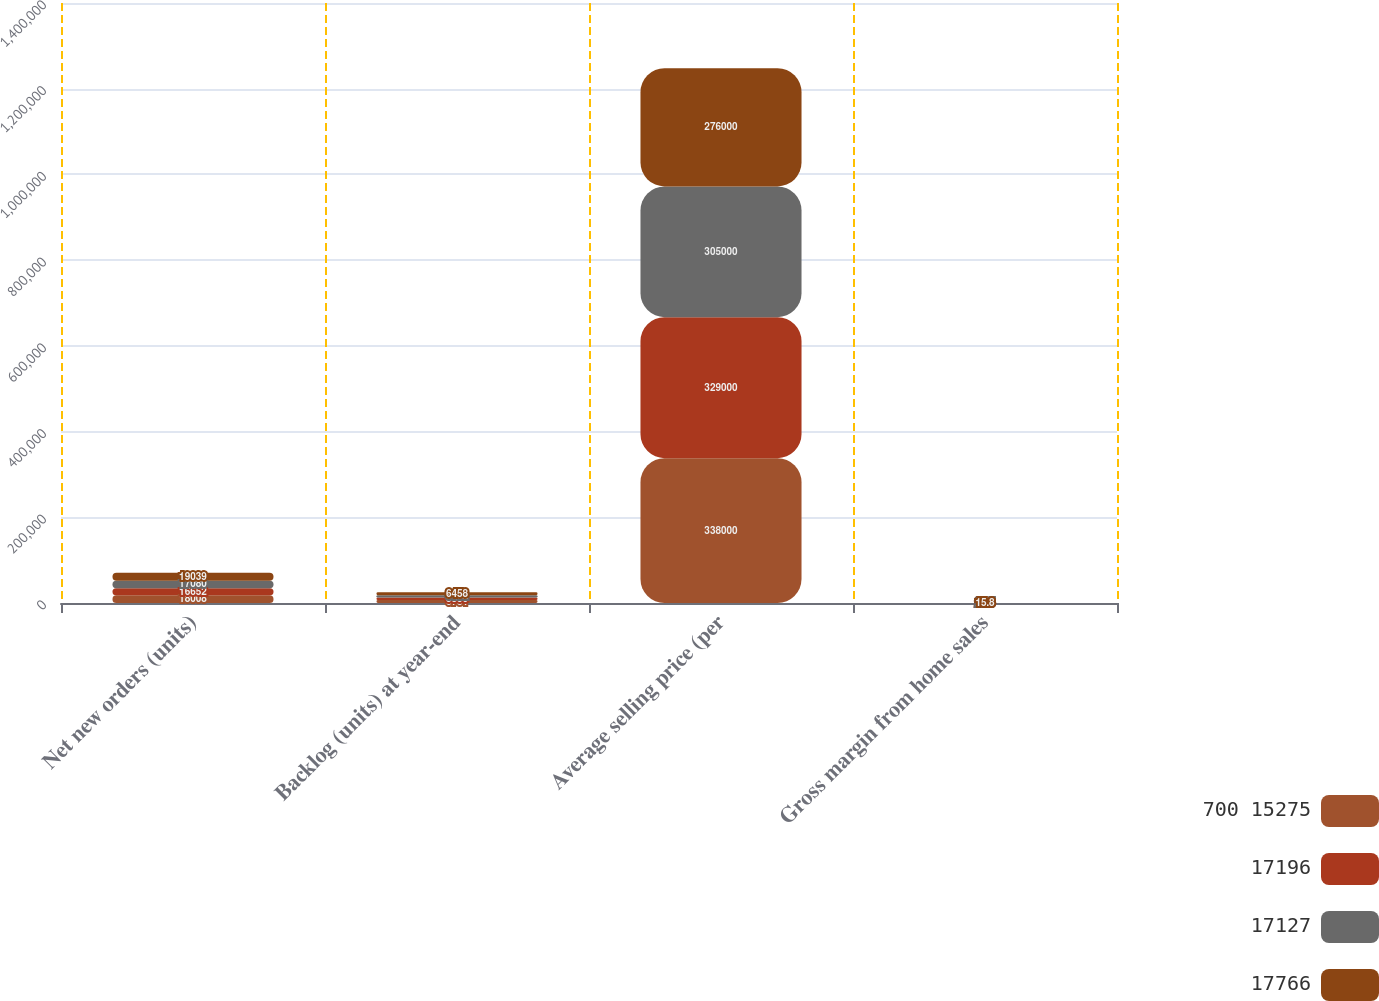Convert chart to OTSL. <chart><loc_0><loc_0><loc_500><loc_500><stacked_bar_chart><ecel><fcel>Net new orders (units)<fcel>Backlog (units) at year-end<fcel>Average selling price (per<fcel>Gross margin from home sales<nl><fcel>700 15275<fcel>18008<fcel>6731<fcel>338000<fcel>23.3<nl><fcel>17196<fcel>16652<fcel>5850<fcel>329000<fcel>23.3<nl><fcel>17127<fcel>17080<fcel>5772<fcel>305000<fcel>20.5<nl><fcel>17766<fcel>19039<fcel>6458<fcel>276000<fcel>15.8<nl></chart> 